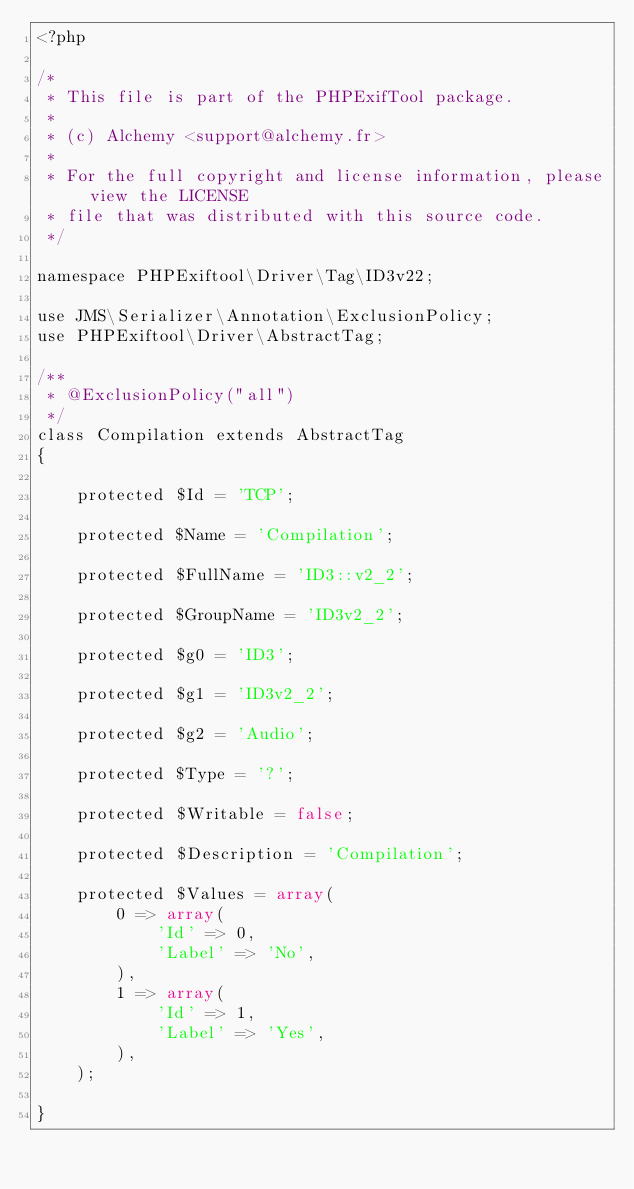Convert code to text. <code><loc_0><loc_0><loc_500><loc_500><_PHP_><?php

/*
 * This file is part of the PHPExifTool package.
 *
 * (c) Alchemy <support@alchemy.fr>
 *
 * For the full copyright and license information, please view the LICENSE
 * file that was distributed with this source code.
 */

namespace PHPExiftool\Driver\Tag\ID3v22;

use JMS\Serializer\Annotation\ExclusionPolicy;
use PHPExiftool\Driver\AbstractTag;

/**
 * @ExclusionPolicy("all")
 */
class Compilation extends AbstractTag
{

    protected $Id = 'TCP';

    protected $Name = 'Compilation';

    protected $FullName = 'ID3::v2_2';

    protected $GroupName = 'ID3v2_2';

    protected $g0 = 'ID3';

    protected $g1 = 'ID3v2_2';

    protected $g2 = 'Audio';

    protected $Type = '?';

    protected $Writable = false;

    protected $Description = 'Compilation';

    protected $Values = array(
        0 => array(
            'Id' => 0,
            'Label' => 'No',
        ),
        1 => array(
            'Id' => 1,
            'Label' => 'Yes',
        ),
    );

}
</code> 